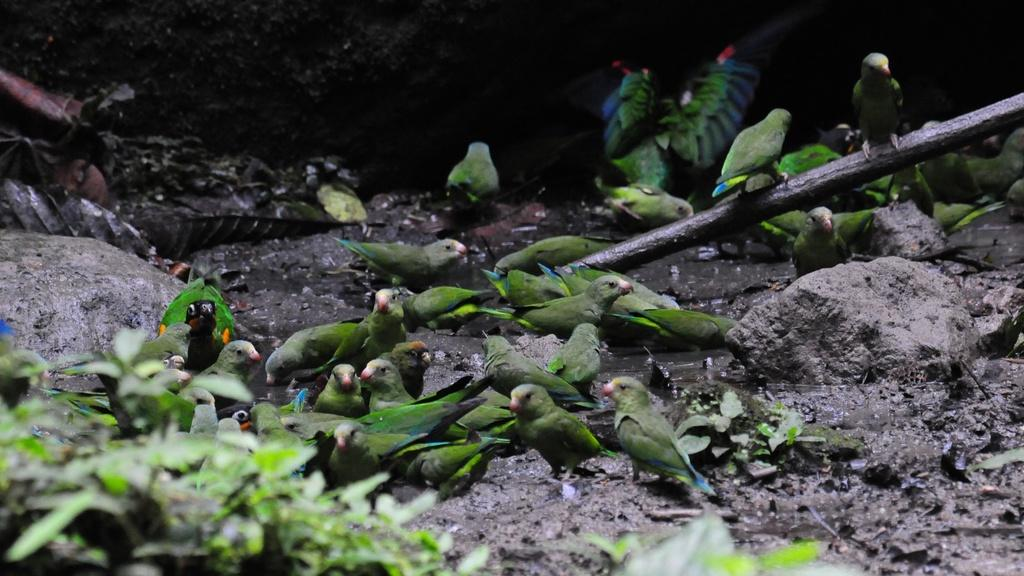What are the birds standing on in the image? The birds are standing on the mud in the image. What other objects can be seen in the image besides the birds? There are rocks and plants visible in the image. Can you describe the rod in the image? Yes, there appears to be a rod in the image. What type of cheese is being grated by the birds in the image? There is no cheese present in the image; the birds are standing on mud. Can you hear the voice of the plants in the image? Plants do not have voices, and there is no indication of any voice in the image. 